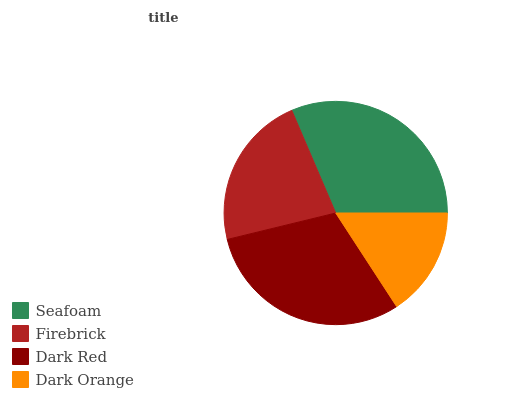Is Dark Orange the minimum?
Answer yes or no. Yes. Is Seafoam the maximum?
Answer yes or no. Yes. Is Firebrick the minimum?
Answer yes or no. No. Is Firebrick the maximum?
Answer yes or no. No. Is Seafoam greater than Firebrick?
Answer yes or no. Yes. Is Firebrick less than Seafoam?
Answer yes or no. Yes. Is Firebrick greater than Seafoam?
Answer yes or no. No. Is Seafoam less than Firebrick?
Answer yes or no. No. Is Dark Red the high median?
Answer yes or no. Yes. Is Firebrick the low median?
Answer yes or no. Yes. Is Firebrick the high median?
Answer yes or no. No. Is Dark Red the low median?
Answer yes or no. No. 